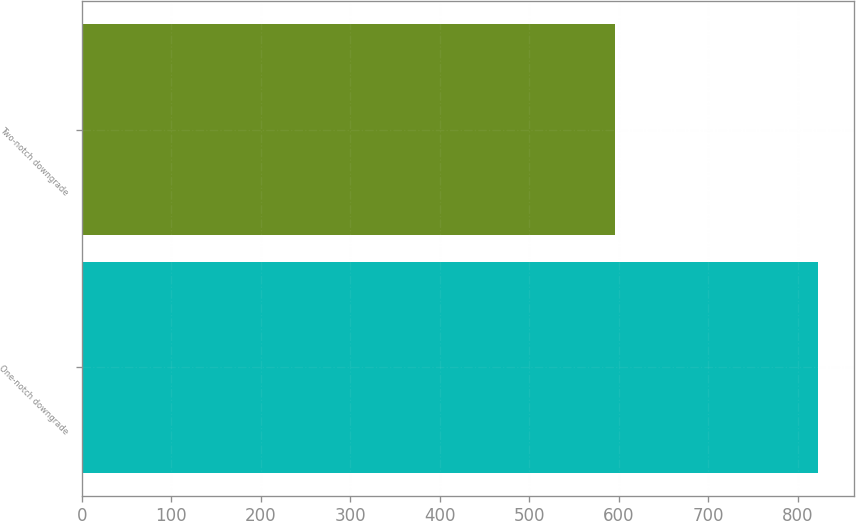Convert chart to OTSL. <chart><loc_0><loc_0><loc_500><loc_500><bar_chart><fcel>One-notch downgrade<fcel>Two-notch downgrade<nl><fcel>822<fcel>596<nl></chart> 